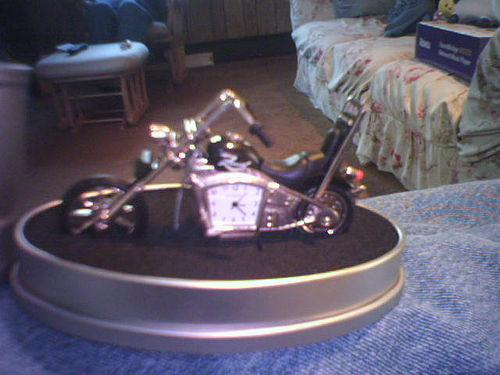What best describes the size of the motorcycle? miniature 